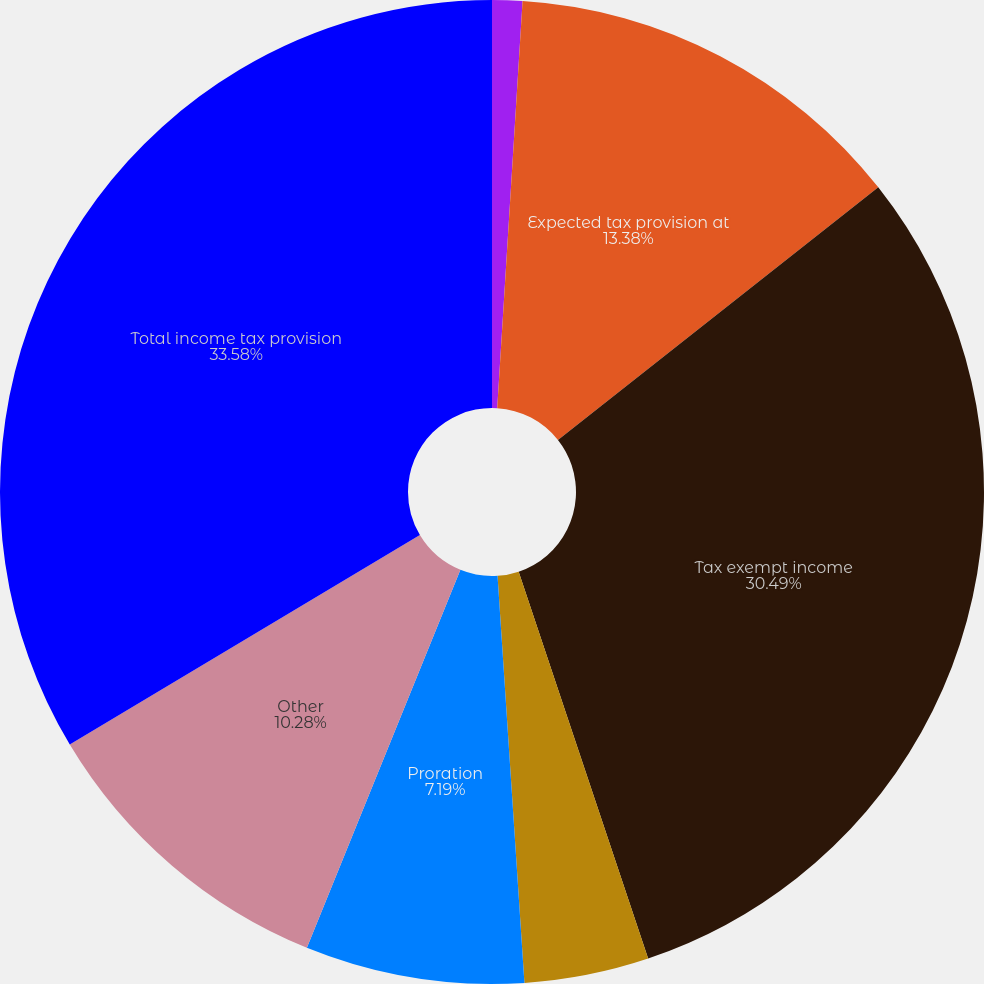<chart> <loc_0><loc_0><loc_500><loc_500><pie_chart><fcel>(Dollars in thousands)<fcel>Expected tax provision at<fcel>Tax exempt income<fcel>Dividend received deduction<fcel>Proration<fcel>Other<fcel>Total income tax provision<nl><fcel>0.99%<fcel>13.38%<fcel>30.49%<fcel>4.09%<fcel>7.19%<fcel>10.28%<fcel>33.58%<nl></chart> 